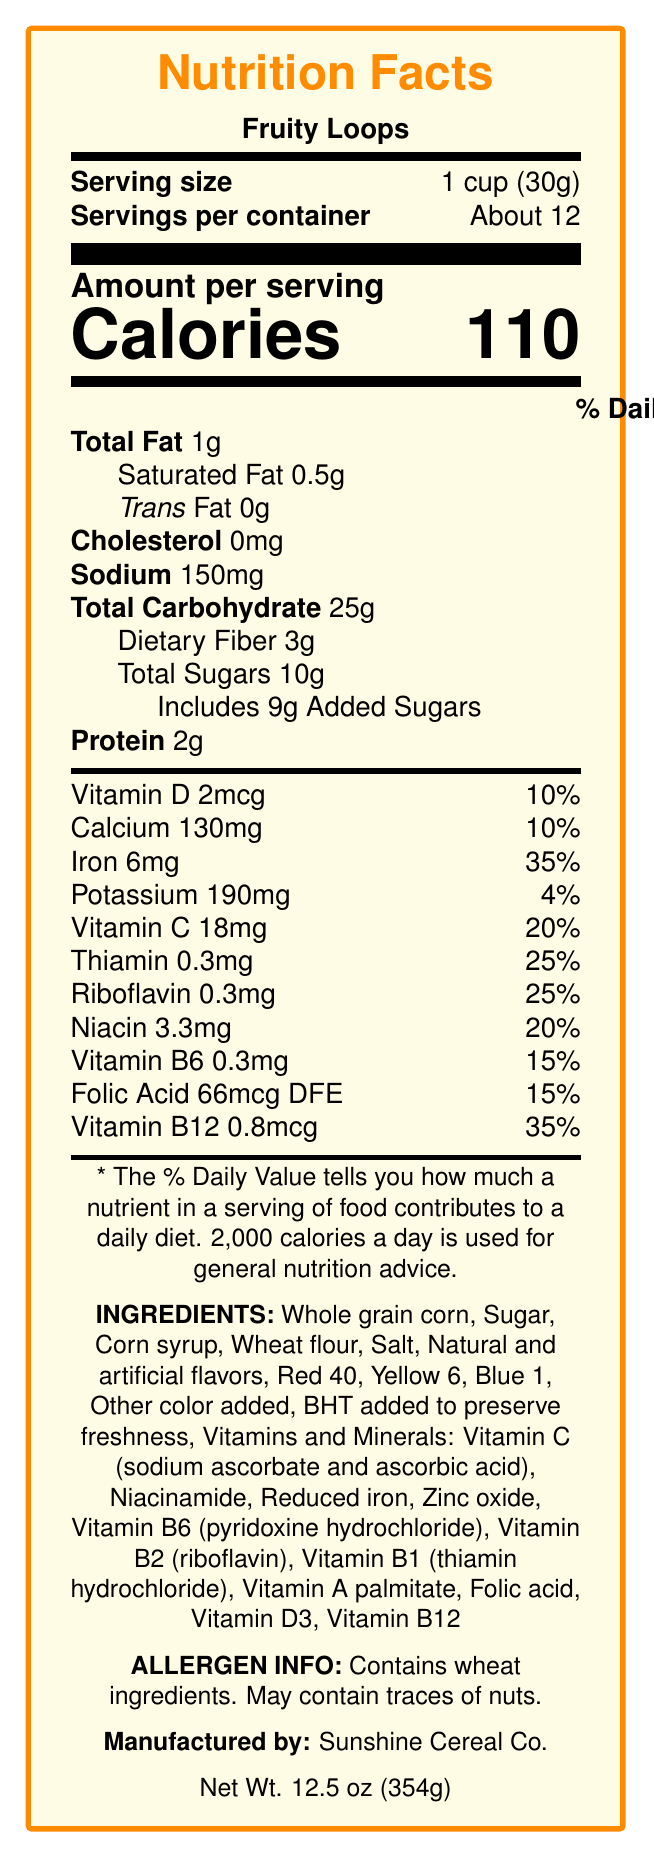what is the serving size of Fruity Loops? The serving size is clearly stated at the top of the nutrition facts section.
Answer: 1 cup (30g) how many calories are in one serving? The amount of calories per serving is prominently displayed under "Amount per serving."
Answer: 110 how much total fat does one serving of this cereal contain? The total fat content is listed right below the calories section.
Answer: 1g what is the percentage of daily value for iron in one serving? The daily value percentage for iron is provided in the vitamins and minerals section.
Answer: 35% what ingredient is responsible for preserving freshness? In the ingredients list, it mentions "BHT added to preserve freshness."
Answer: BHT which of the following is NOT an ingredient in Fruity Loops? A. Whole grain corn B. Red 40 C. Soy lecithin D. Sugar. Soy lecithin is not listed in the ingredients while all other options are listed.
Answer: C how many grams of dietary fiber are in one serving? Dietary fiber amount per serving is listed under total carbohydrates.
Answer: 3g is there any cholesterol in Fruity Loops? The nutrition facts indicate 0mg of cholesterol per serving.
Answer: No what is the allergen information provided on the label? The allergen information is clearly stated at the end of the ingredients section.
Answer: Contains wheat ingredients. May contain traces of nuts. what are the total carbohydrates in one serving of this cereal? A. 14g B. 18g C. 25g D. 30g The total carbohydrates per serving are listed as 25g.
Answer: C summarize the overall information presented in this document. The document is a comprehensive nutrition label for Fruity Loops cereal, detailing its nutritional content, ingredient list, allergen information, manufacturer, and packaging description.
Answer: The document provides the nutrition facts for Fruity Loops cereal. It includes details on serving size, calories, fat, cholesterol, sodium, carbohydrates, dietary fiber, sugars, protein, and various vitamins and minerals with their respective daily values. Ingredients and allergen information are also provided. Additionally, it mentions that the cereal is manufactured by Sunshine Cereal Co. and is packaged in a bright yellow box with colorful fruit characters. how many servings are approximately in one container of Fruity Loops? The servings per container are mentioned right below the serving size information.
Answer: About 12 can it be determined how much zinc is in one serving of Fruity Loops? The document does not provide any information about the zinc content per serving.
Answer: Not enough information how much calcium is in one serving of cereal? The amount of calcium per serving is listed in the vitamins and minerals section.
Answer: 130mg what vitamins and minerals have the highest percentage of the daily value in Fruity Loops? The nutrition facts show that iron and vitamin B12 both have a daily value of 35%, which is the highest among the listed nutrients.
Answer: Iron and Vitamin B12 (both 35%) 